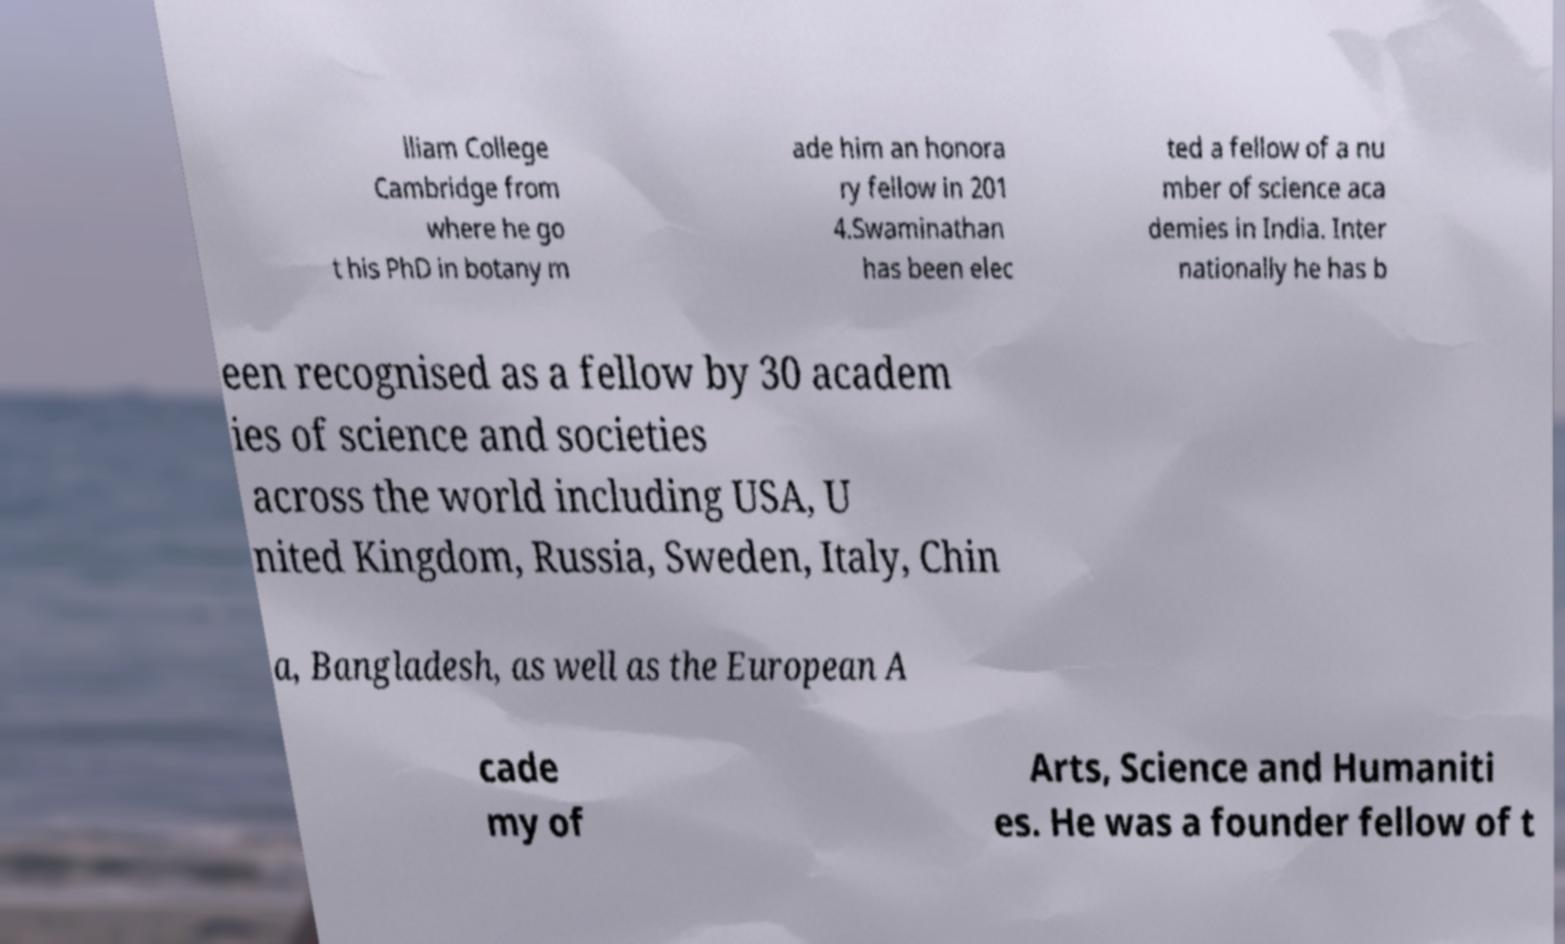There's text embedded in this image that I need extracted. Can you transcribe it verbatim? lliam College Cambridge from where he go t his PhD in botany m ade him an honora ry fellow in 201 4.Swaminathan has been elec ted a fellow of a nu mber of science aca demies in India. Inter nationally he has b een recognised as a fellow by 30 academ ies of science and societies across the world including USA, U nited Kingdom, Russia, Sweden, Italy, Chin a, Bangladesh, as well as the European A cade my of Arts, Science and Humaniti es. He was a founder fellow of t 